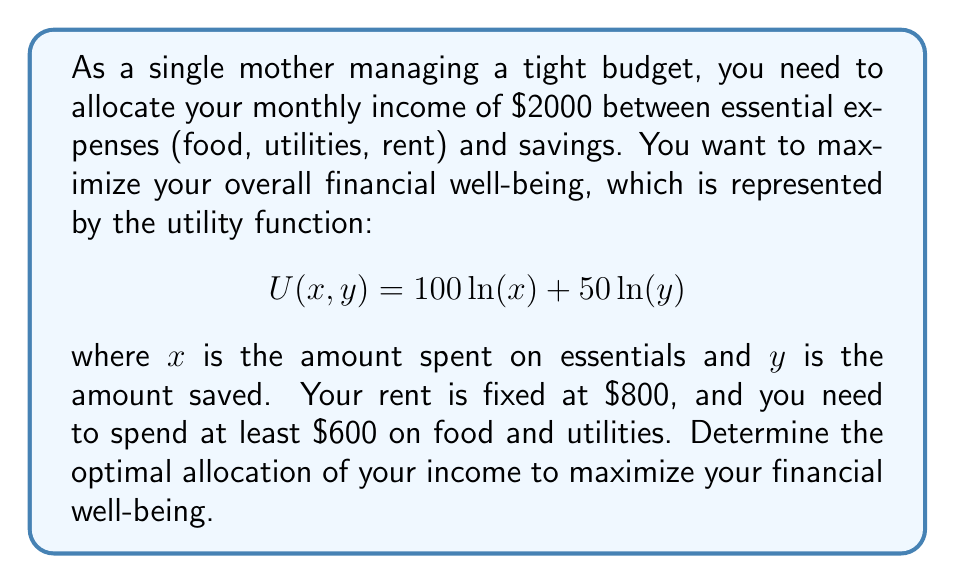Solve this math problem. 1. Set up the nonlinear programming problem:
   Maximize $U(x, y) = 100\ln(x) + 50\ln(y)$
   Subject to:
   $x + y \leq 2000 - 800$ (budget constraint after rent)
   $x \geq 600$ (minimum essentials)
   $x, y \geq 0$ (non-negativity constraints)

2. Use the Karush-Kuhn-Tucker (KKT) conditions to solve:
   Lagrangian: $L = 100\ln(x) + 50\ln(y) + \lambda(1200 - x - y) + \mu(x - 600)$

3. KKT conditions:
   $\frac{\partial L}{\partial x} = \frac{100}{x} - \lambda + \mu = 0$
   $\frac{\partial L}{\partial y} = \frac{50}{y} - \lambda = 0$
   $\lambda(1200 - x - y) = 0$
   $\mu(x - 600) = 0$

4. Solve the system:
   From $\frac{\partial L}{\partial y} = 0$, we get $\lambda = \frac{50}{y}$
   Substituting into $\frac{\partial L}{\partial x} = 0$:
   $\frac{100}{x} - \frac{50}{y} + \mu = 0$

5. Case 1: If $x > 600$, then $\mu = 0$:
   $\frac{100}{x} = \frac{50}{y}$, which implies $y = \frac{x}{2}$
   Using the budget constraint: $x + \frac{x}{2} = 1200$
   Solving: $x = 800, y = 400$

6. Case 2: If $x = 600$, then:
   $y = 1200 - 600 = 600$

7. Compare utilities:
   $U(800, 400) = 100\ln(800) + 50\ln(400) \approx 1330.48$
   $U(600, 600) = 100\ln(600) + 50\ln(600) \approx 1308.29$

8. The maximum utility is achieved with $x = 800$ and $y = 400$.
Answer: Essentials: $800, Savings: $400 